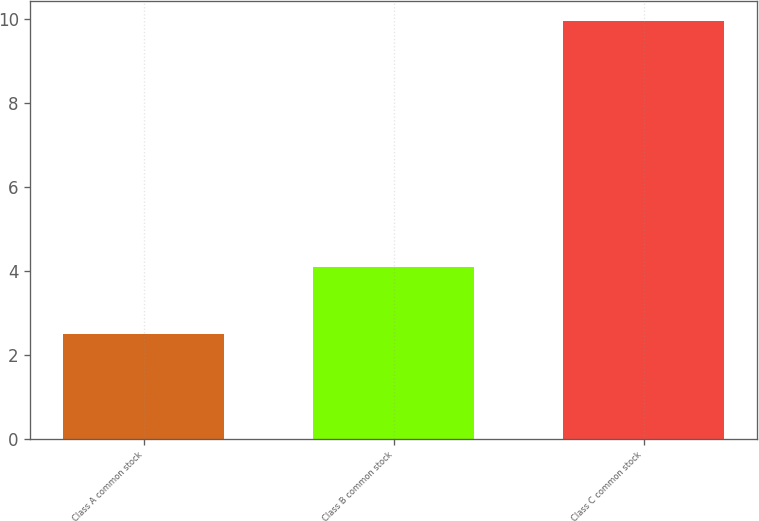Convert chart. <chart><loc_0><loc_0><loc_500><loc_500><bar_chart><fcel>Class A common stock<fcel>Class B common stock<fcel>Class C common stock<nl><fcel>2.49<fcel>4.1<fcel>9.94<nl></chart> 